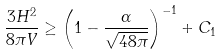Convert formula to latex. <formula><loc_0><loc_0><loc_500><loc_500>\frac { 3 H ^ { 2 } } { 8 \pi V } \geq \left ( 1 - \frac { \alpha } { \sqrt { 4 8 \pi } } \right ) ^ { - 1 } + C _ { 1 }</formula> 